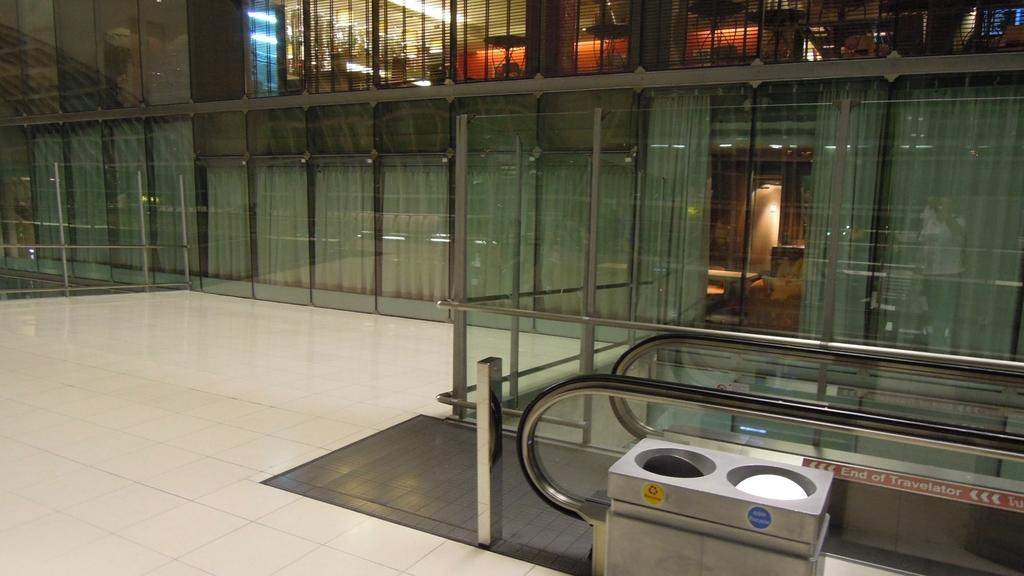Provide a one-sentence caption for the provided image. A label on an escalator says End of Traveler. 